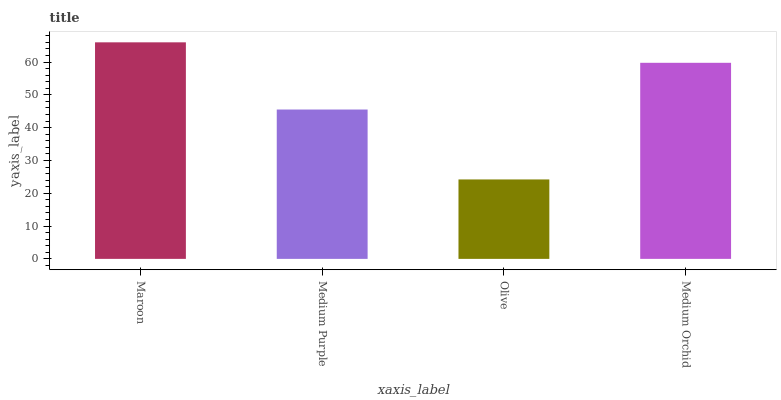Is Olive the minimum?
Answer yes or no. Yes. Is Maroon the maximum?
Answer yes or no. Yes. Is Medium Purple the minimum?
Answer yes or no. No. Is Medium Purple the maximum?
Answer yes or no. No. Is Maroon greater than Medium Purple?
Answer yes or no. Yes. Is Medium Purple less than Maroon?
Answer yes or no. Yes. Is Medium Purple greater than Maroon?
Answer yes or no. No. Is Maroon less than Medium Purple?
Answer yes or no. No. Is Medium Orchid the high median?
Answer yes or no. Yes. Is Medium Purple the low median?
Answer yes or no. Yes. Is Maroon the high median?
Answer yes or no. No. Is Olive the low median?
Answer yes or no. No. 